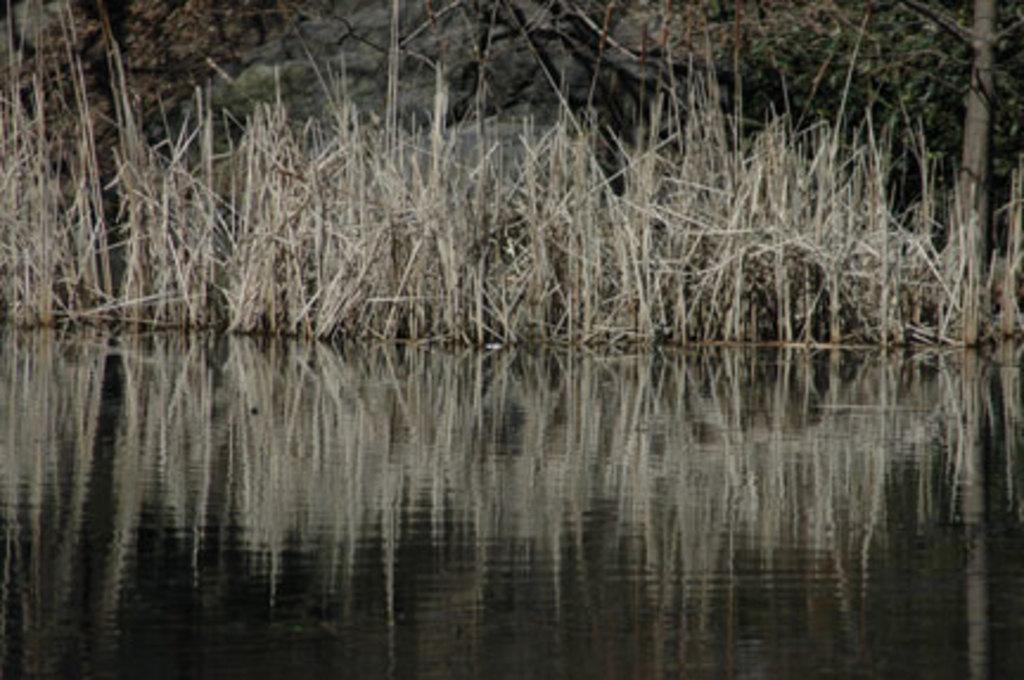Could you give a brief overview of what you see in this image? This picture is clicked outside. In the foreground we can see a water body. In the center we can see the grass. In the background we can see the trees. 